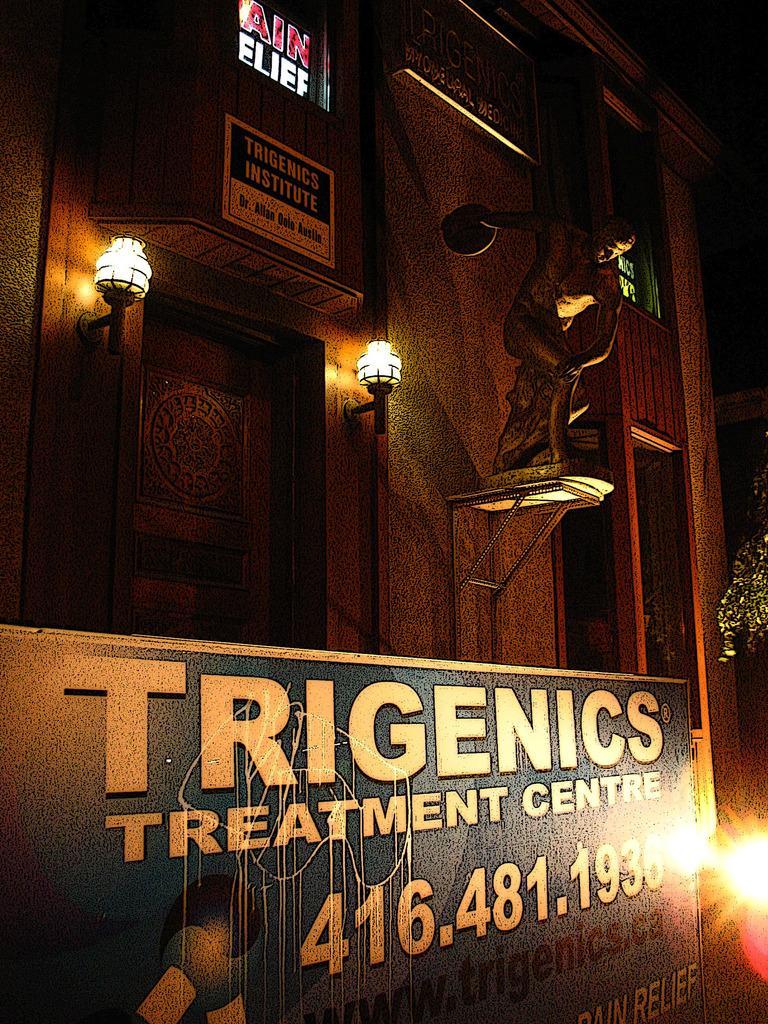Could you give a brief overview of what you see in this image? In this image I can see at the bottom there is a board, on the right side there is a light. In the middle there are lights to this building. 